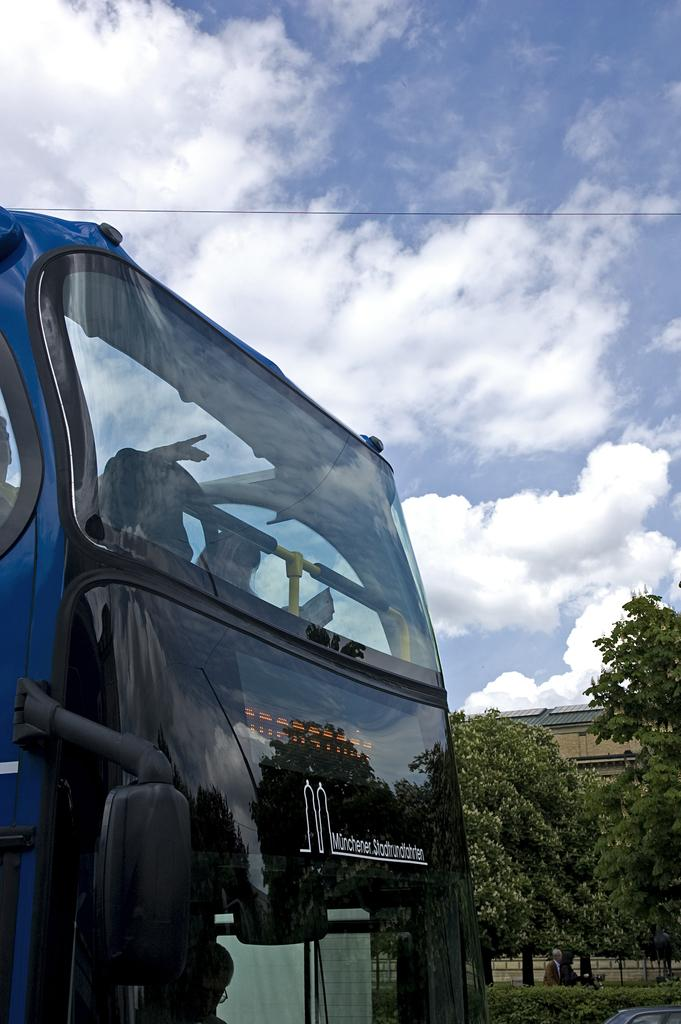What is the main subject of the image? There is a vehicle in the image. What other elements can be seen in the image besides the vehicle? There are plants, trees, a building, and the sky visible in the image. Can you describe the sky in the image? The sky is visible in the image, and there are clouds present. What type of stew is being served in the image? There is no stew present in the image. Can you tell me how many oranges are on the vehicle in the image? There are no oranges present in the image. 